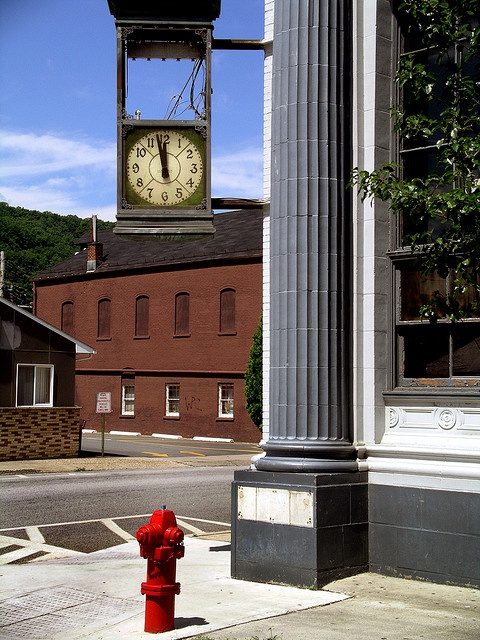Describe the objects in this image and their specific colors. I can see clock in blue, black, tan, gray, and olive tones and fire hydrant in blue, black, maroon, and red tones in this image. 